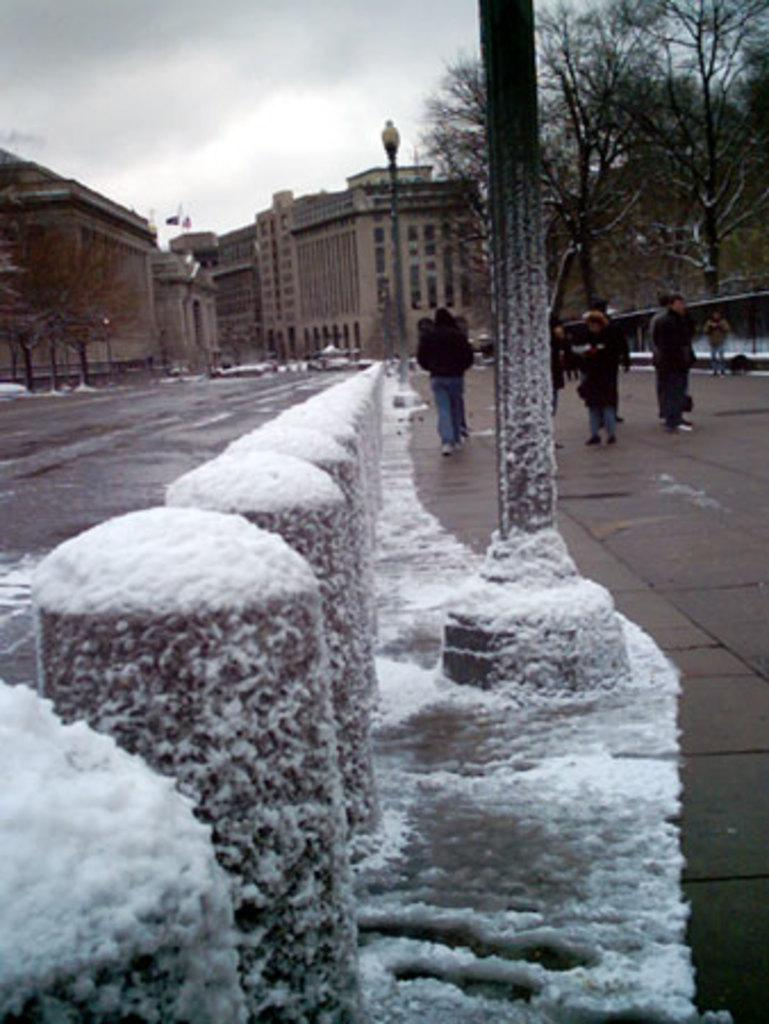What is covered with snow in the image? There are barriers covered with snow in the image. What are the people in the image doing? There are people walking on the road in the image. What can be seen in the background of the image? There are buildings, trees, and poles in the background of the image. What type of birthday celebration is taking place in the image? There is no birthday celebration present in the image. Can you see any robins in the image? There are no robins present in the image. 